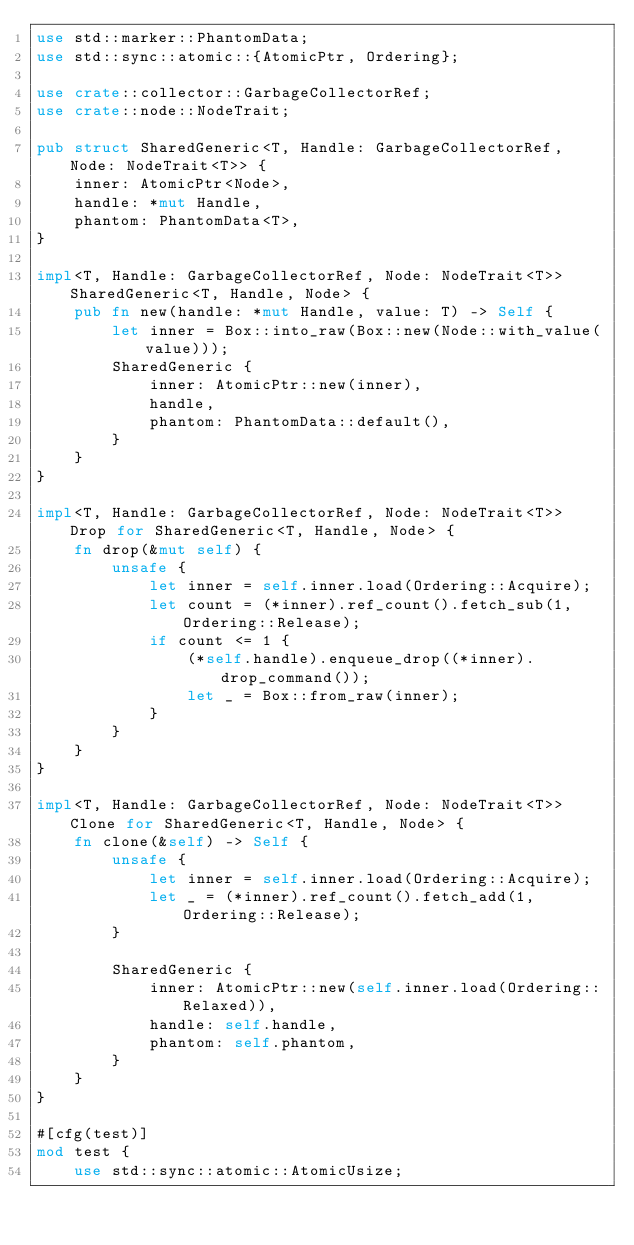Convert code to text. <code><loc_0><loc_0><loc_500><loc_500><_Rust_>use std::marker::PhantomData;
use std::sync::atomic::{AtomicPtr, Ordering};

use crate::collector::GarbageCollectorRef;
use crate::node::NodeTrait;

pub struct SharedGeneric<T, Handle: GarbageCollectorRef, Node: NodeTrait<T>> {
    inner: AtomicPtr<Node>,
    handle: *mut Handle,
    phantom: PhantomData<T>,
}

impl<T, Handle: GarbageCollectorRef, Node: NodeTrait<T>> SharedGeneric<T, Handle, Node> {
    pub fn new(handle: *mut Handle, value: T) -> Self {
        let inner = Box::into_raw(Box::new(Node::with_value(value)));
        SharedGeneric {
            inner: AtomicPtr::new(inner),
            handle,
            phantom: PhantomData::default(),
        }
    }
}

impl<T, Handle: GarbageCollectorRef, Node: NodeTrait<T>> Drop for SharedGeneric<T, Handle, Node> {
    fn drop(&mut self) {
        unsafe {
            let inner = self.inner.load(Ordering::Acquire);
            let count = (*inner).ref_count().fetch_sub(1, Ordering::Release);
            if count <= 1 {
                (*self.handle).enqueue_drop((*inner).drop_command());
                let _ = Box::from_raw(inner);
            }
        }
    }
}

impl<T, Handle: GarbageCollectorRef, Node: NodeTrait<T>> Clone for SharedGeneric<T, Handle, Node> {
    fn clone(&self) -> Self {
        unsafe {
            let inner = self.inner.load(Ordering::Acquire);
            let _ = (*inner).ref_count().fetch_add(1, Ordering::Release);
        }

        SharedGeneric {
            inner: AtomicPtr::new(self.inner.load(Ordering::Relaxed)),
            handle: self.handle,
            phantom: self.phantom,
        }
    }
}

#[cfg(test)]
mod test {
    use std::sync::atomic::AtomicUsize;</code> 